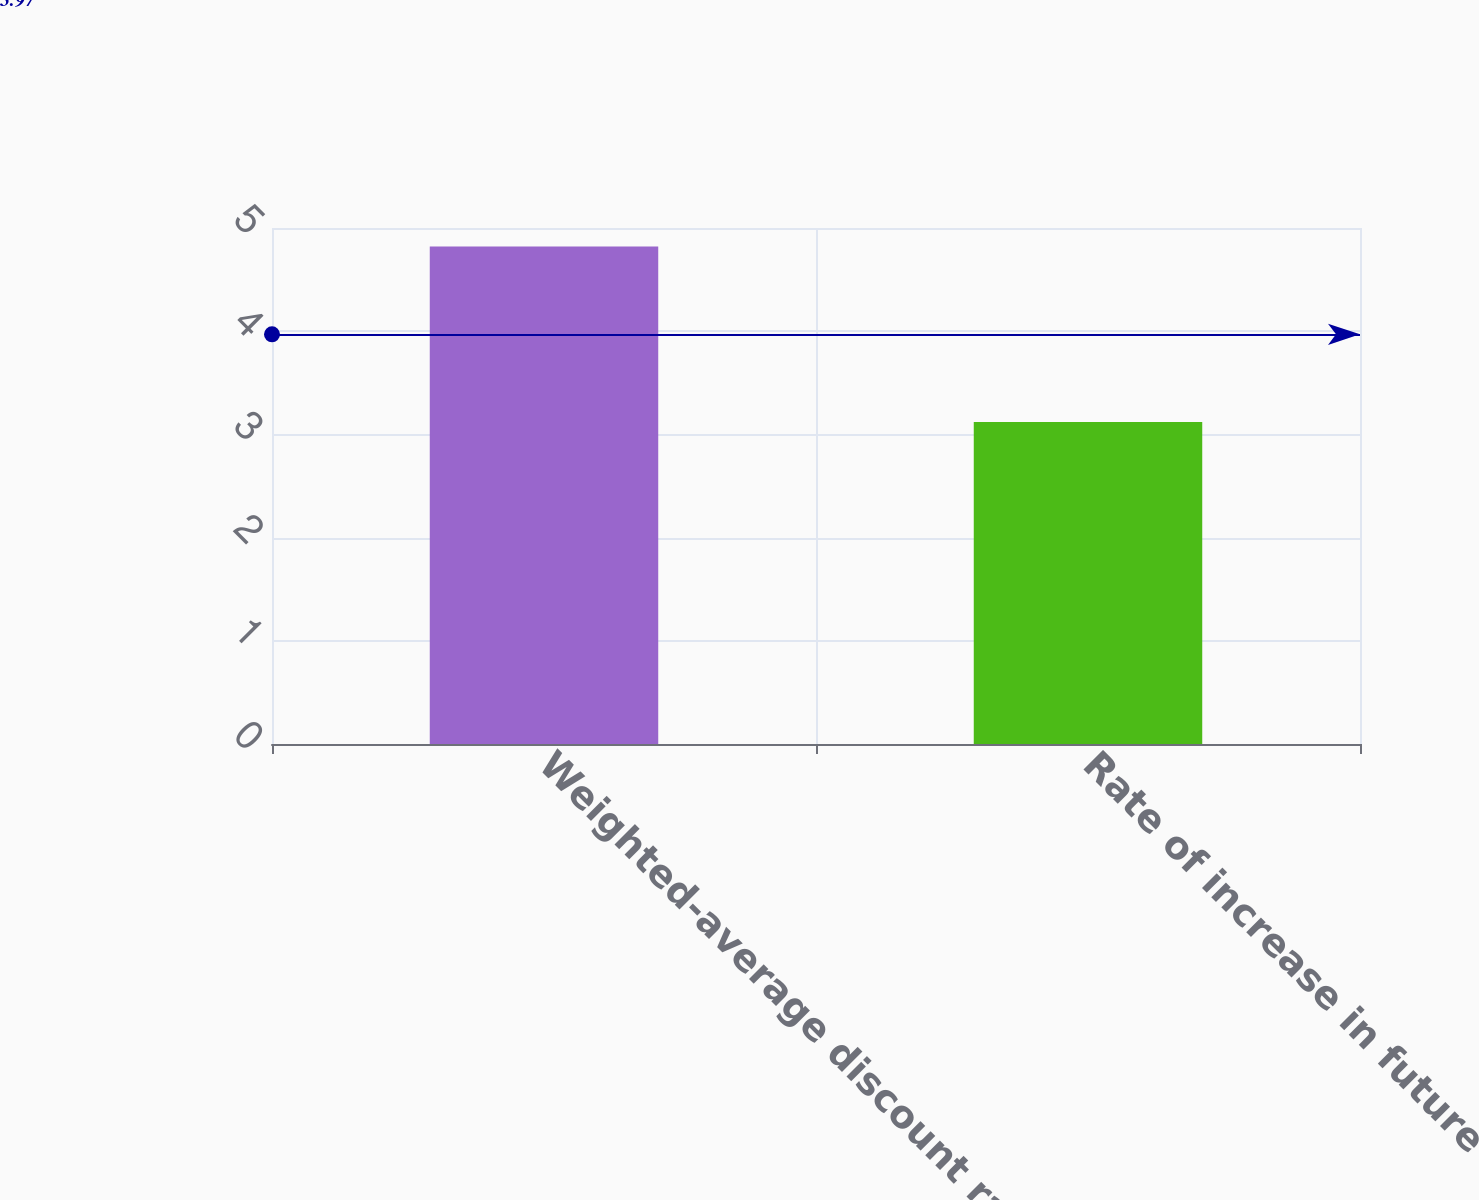Convert chart to OTSL. <chart><loc_0><loc_0><loc_500><loc_500><bar_chart><fcel>Weighted-average discount rate<fcel>Rate of increase in future<nl><fcel>4.82<fcel>3.12<nl></chart> 